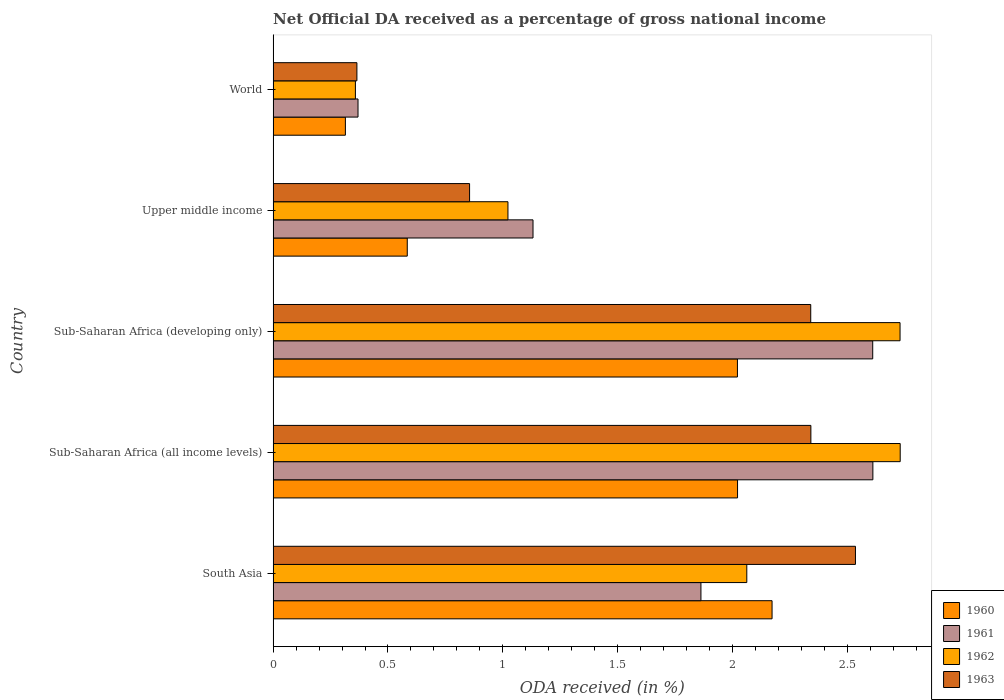Are the number of bars per tick equal to the number of legend labels?
Your answer should be very brief. Yes. How many bars are there on the 1st tick from the top?
Provide a succinct answer. 4. What is the label of the 4th group of bars from the top?
Make the answer very short. Sub-Saharan Africa (all income levels). What is the net official DA received in 1961 in Sub-Saharan Africa (all income levels)?
Keep it short and to the point. 2.61. Across all countries, what is the maximum net official DA received in 1960?
Make the answer very short. 2.17. Across all countries, what is the minimum net official DA received in 1960?
Offer a terse response. 0.31. In which country was the net official DA received in 1960 maximum?
Offer a terse response. South Asia. What is the total net official DA received in 1963 in the graph?
Your answer should be compact. 8.44. What is the difference between the net official DA received in 1961 in South Asia and that in Sub-Saharan Africa (all income levels)?
Provide a short and direct response. -0.75. What is the difference between the net official DA received in 1960 in Sub-Saharan Africa (all income levels) and the net official DA received in 1961 in Upper middle income?
Ensure brevity in your answer.  0.89. What is the average net official DA received in 1962 per country?
Offer a terse response. 1.78. What is the difference between the net official DA received in 1960 and net official DA received in 1961 in World?
Offer a very short reply. -0.05. In how many countries, is the net official DA received in 1961 greater than 1.3 %?
Give a very brief answer. 3. What is the ratio of the net official DA received in 1961 in South Asia to that in World?
Offer a very short reply. 5.04. What is the difference between the highest and the second highest net official DA received in 1963?
Your response must be concise. 0.19. What is the difference between the highest and the lowest net official DA received in 1962?
Provide a short and direct response. 2.37. Is it the case that in every country, the sum of the net official DA received in 1961 and net official DA received in 1960 is greater than the sum of net official DA received in 1962 and net official DA received in 1963?
Offer a very short reply. No. How many bars are there?
Make the answer very short. 20. How many countries are there in the graph?
Make the answer very short. 5. What is the difference between two consecutive major ticks on the X-axis?
Give a very brief answer. 0.5. Does the graph contain grids?
Give a very brief answer. No. Where does the legend appear in the graph?
Your response must be concise. Bottom right. How are the legend labels stacked?
Make the answer very short. Vertical. What is the title of the graph?
Your response must be concise. Net Official DA received as a percentage of gross national income. What is the label or title of the X-axis?
Give a very brief answer. ODA received (in %). What is the label or title of the Y-axis?
Your response must be concise. Country. What is the ODA received (in %) of 1960 in South Asia?
Your answer should be very brief. 2.17. What is the ODA received (in %) in 1961 in South Asia?
Your answer should be compact. 1.86. What is the ODA received (in %) in 1962 in South Asia?
Ensure brevity in your answer.  2.06. What is the ODA received (in %) in 1963 in South Asia?
Provide a short and direct response. 2.53. What is the ODA received (in %) in 1960 in Sub-Saharan Africa (all income levels)?
Ensure brevity in your answer.  2.02. What is the ODA received (in %) in 1961 in Sub-Saharan Africa (all income levels)?
Ensure brevity in your answer.  2.61. What is the ODA received (in %) in 1962 in Sub-Saharan Africa (all income levels)?
Ensure brevity in your answer.  2.73. What is the ODA received (in %) of 1963 in Sub-Saharan Africa (all income levels)?
Ensure brevity in your answer.  2.34. What is the ODA received (in %) in 1960 in Sub-Saharan Africa (developing only)?
Keep it short and to the point. 2.02. What is the ODA received (in %) of 1961 in Sub-Saharan Africa (developing only)?
Make the answer very short. 2.61. What is the ODA received (in %) in 1962 in Sub-Saharan Africa (developing only)?
Offer a very short reply. 2.73. What is the ODA received (in %) of 1963 in Sub-Saharan Africa (developing only)?
Keep it short and to the point. 2.34. What is the ODA received (in %) of 1960 in Upper middle income?
Your answer should be compact. 0.58. What is the ODA received (in %) of 1961 in Upper middle income?
Your answer should be very brief. 1.13. What is the ODA received (in %) of 1962 in Upper middle income?
Your response must be concise. 1.02. What is the ODA received (in %) in 1963 in Upper middle income?
Offer a terse response. 0.86. What is the ODA received (in %) of 1960 in World?
Provide a short and direct response. 0.31. What is the ODA received (in %) of 1961 in World?
Ensure brevity in your answer.  0.37. What is the ODA received (in %) in 1962 in World?
Your answer should be compact. 0.36. What is the ODA received (in %) in 1963 in World?
Your answer should be compact. 0.36. Across all countries, what is the maximum ODA received (in %) in 1960?
Make the answer very short. 2.17. Across all countries, what is the maximum ODA received (in %) in 1961?
Provide a succinct answer. 2.61. Across all countries, what is the maximum ODA received (in %) in 1962?
Your response must be concise. 2.73. Across all countries, what is the maximum ODA received (in %) of 1963?
Give a very brief answer. 2.53. Across all countries, what is the minimum ODA received (in %) of 1960?
Offer a terse response. 0.31. Across all countries, what is the minimum ODA received (in %) of 1961?
Provide a short and direct response. 0.37. Across all countries, what is the minimum ODA received (in %) of 1962?
Ensure brevity in your answer.  0.36. Across all countries, what is the minimum ODA received (in %) of 1963?
Make the answer very short. 0.36. What is the total ODA received (in %) of 1960 in the graph?
Provide a short and direct response. 7.11. What is the total ODA received (in %) of 1961 in the graph?
Offer a terse response. 8.58. What is the total ODA received (in %) of 1962 in the graph?
Ensure brevity in your answer.  8.9. What is the total ODA received (in %) of 1963 in the graph?
Provide a short and direct response. 8.44. What is the difference between the ODA received (in %) of 1960 in South Asia and that in Sub-Saharan Africa (all income levels)?
Offer a very short reply. 0.15. What is the difference between the ODA received (in %) in 1961 in South Asia and that in Sub-Saharan Africa (all income levels)?
Provide a succinct answer. -0.75. What is the difference between the ODA received (in %) of 1962 in South Asia and that in Sub-Saharan Africa (all income levels)?
Your response must be concise. -0.67. What is the difference between the ODA received (in %) in 1963 in South Asia and that in Sub-Saharan Africa (all income levels)?
Your answer should be very brief. 0.19. What is the difference between the ODA received (in %) in 1960 in South Asia and that in Sub-Saharan Africa (developing only)?
Offer a terse response. 0.15. What is the difference between the ODA received (in %) of 1961 in South Asia and that in Sub-Saharan Africa (developing only)?
Provide a succinct answer. -0.75. What is the difference between the ODA received (in %) in 1962 in South Asia and that in Sub-Saharan Africa (developing only)?
Offer a very short reply. -0.67. What is the difference between the ODA received (in %) in 1963 in South Asia and that in Sub-Saharan Africa (developing only)?
Make the answer very short. 0.19. What is the difference between the ODA received (in %) of 1960 in South Asia and that in Upper middle income?
Your response must be concise. 1.59. What is the difference between the ODA received (in %) in 1961 in South Asia and that in Upper middle income?
Provide a short and direct response. 0.73. What is the difference between the ODA received (in %) of 1962 in South Asia and that in Upper middle income?
Provide a short and direct response. 1.04. What is the difference between the ODA received (in %) of 1963 in South Asia and that in Upper middle income?
Provide a short and direct response. 1.68. What is the difference between the ODA received (in %) in 1960 in South Asia and that in World?
Your answer should be compact. 1.86. What is the difference between the ODA received (in %) in 1961 in South Asia and that in World?
Provide a succinct answer. 1.49. What is the difference between the ODA received (in %) of 1962 in South Asia and that in World?
Offer a very short reply. 1.7. What is the difference between the ODA received (in %) in 1963 in South Asia and that in World?
Offer a very short reply. 2.17. What is the difference between the ODA received (in %) in 1960 in Sub-Saharan Africa (all income levels) and that in Sub-Saharan Africa (developing only)?
Offer a terse response. 0. What is the difference between the ODA received (in %) in 1961 in Sub-Saharan Africa (all income levels) and that in Sub-Saharan Africa (developing only)?
Your response must be concise. 0. What is the difference between the ODA received (in %) of 1962 in Sub-Saharan Africa (all income levels) and that in Sub-Saharan Africa (developing only)?
Give a very brief answer. 0. What is the difference between the ODA received (in %) in 1963 in Sub-Saharan Africa (all income levels) and that in Sub-Saharan Africa (developing only)?
Provide a short and direct response. 0. What is the difference between the ODA received (in %) in 1960 in Sub-Saharan Africa (all income levels) and that in Upper middle income?
Provide a succinct answer. 1.44. What is the difference between the ODA received (in %) in 1961 in Sub-Saharan Africa (all income levels) and that in Upper middle income?
Give a very brief answer. 1.48. What is the difference between the ODA received (in %) in 1962 in Sub-Saharan Africa (all income levels) and that in Upper middle income?
Provide a succinct answer. 1.71. What is the difference between the ODA received (in %) in 1963 in Sub-Saharan Africa (all income levels) and that in Upper middle income?
Offer a terse response. 1.49. What is the difference between the ODA received (in %) in 1960 in Sub-Saharan Africa (all income levels) and that in World?
Your answer should be compact. 1.71. What is the difference between the ODA received (in %) in 1961 in Sub-Saharan Africa (all income levels) and that in World?
Ensure brevity in your answer.  2.24. What is the difference between the ODA received (in %) of 1962 in Sub-Saharan Africa (all income levels) and that in World?
Keep it short and to the point. 2.37. What is the difference between the ODA received (in %) of 1963 in Sub-Saharan Africa (all income levels) and that in World?
Keep it short and to the point. 1.98. What is the difference between the ODA received (in %) in 1960 in Sub-Saharan Africa (developing only) and that in Upper middle income?
Ensure brevity in your answer.  1.44. What is the difference between the ODA received (in %) of 1961 in Sub-Saharan Africa (developing only) and that in Upper middle income?
Provide a succinct answer. 1.48. What is the difference between the ODA received (in %) of 1962 in Sub-Saharan Africa (developing only) and that in Upper middle income?
Offer a terse response. 1.71. What is the difference between the ODA received (in %) of 1963 in Sub-Saharan Africa (developing only) and that in Upper middle income?
Provide a short and direct response. 1.49. What is the difference between the ODA received (in %) of 1960 in Sub-Saharan Africa (developing only) and that in World?
Your answer should be compact. 1.71. What is the difference between the ODA received (in %) in 1961 in Sub-Saharan Africa (developing only) and that in World?
Ensure brevity in your answer.  2.24. What is the difference between the ODA received (in %) of 1962 in Sub-Saharan Africa (developing only) and that in World?
Provide a succinct answer. 2.37. What is the difference between the ODA received (in %) in 1963 in Sub-Saharan Africa (developing only) and that in World?
Keep it short and to the point. 1.98. What is the difference between the ODA received (in %) in 1960 in Upper middle income and that in World?
Offer a terse response. 0.27. What is the difference between the ODA received (in %) in 1961 in Upper middle income and that in World?
Ensure brevity in your answer.  0.76. What is the difference between the ODA received (in %) of 1962 in Upper middle income and that in World?
Keep it short and to the point. 0.66. What is the difference between the ODA received (in %) of 1963 in Upper middle income and that in World?
Offer a very short reply. 0.49. What is the difference between the ODA received (in %) in 1960 in South Asia and the ODA received (in %) in 1961 in Sub-Saharan Africa (all income levels)?
Give a very brief answer. -0.44. What is the difference between the ODA received (in %) of 1960 in South Asia and the ODA received (in %) of 1962 in Sub-Saharan Africa (all income levels)?
Offer a very short reply. -0.56. What is the difference between the ODA received (in %) in 1960 in South Asia and the ODA received (in %) in 1963 in Sub-Saharan Africa (all income levels)?
Your answer should be very brief. -0.17. What is the difference between the ODA received (in %) in 1961 in South Asia and the ODA received (in %) in 1962 in Sub-Saharan Africa (all income levels)?
Keep it short and to the point. -0.87. What is the difference between the ODA received (in %) of 1961 in South Asia and the ODA received (in %) of 1963 in Sub-Saharan Africa (all income levels)?
Provide a short and direct response. -0.48. What is the difference between the ODA received (in %) of 1962 in South Asia and the ODA received (in %) of 1963 in Sub-Saharan Africa (all income levels)?
Offer a terse response. -0.28. What is the difference between the ODA received (in %) in 1960 in South Asia and the ODA received (in %) in 1961 in Sub-Saharan Africa (developing only)?
Keep it short and to the point. -0.44. What is the difference between the ODA received (in %) of 1960 in South Asia and the ODA received (in %) of 1962 in Sub-Saharan Africa (developing only)?
Your answer should be very brief. -0.56. What is the difference between the ODA received (in %) in 1960 in South Asia and the ODA received (in %) in 1963 in Sub-Saharan Africa (developing only)?
Keep it short and to the point. -0.17. What is the difference between the ODA received (in %) of 1961 in South Asia and the ODA received (in %) of 1962 in Sub-Saharan Africa (developing only)?
Your response must be concise. -0.87. What is the difference between the ODA received (in %) of 1961 in South Asia and the ODA received (in %) of 1963 in Sub-Saharan Africa (developing only)?
Make the answer very short. -0.48. What is the difference between the ODA received (in %) of 1962 in South Asia and the ODA received (in %) of 1963 in Sub-Saharan Africa (developing only)?
Offer a terse response. -0.28. What is the difference between the ODA received (in %) of 1960 in South Asia and the ODA received (in %) of 1961 in Upper middle income?
Offer a terse response. 1.04. What is the difference between the ODA received (in %) of 1960 in South Asia and the ODA received (in %) of 1962 in Upper middle income?
Keep it short and to the point. 1.15. What is the difference between the ODA received (in %) in 1960 in South Asia and the ODA received (in %) in 1963 in Upper middle income?
Your answer should be very brief. 1.32. What is the difference between the ODA received (in %) of 1961 in South Asia and the ODA received (in %) of 1962 in Upper middle income?
Provide a succinct answer. 0.84. What is the difference between the ODA received (in %) of 1961 in South Asia and the ODA received (in %) of 1963 in Upper middle income?
Ensure brevity in your answer.  1.01. What is the difference between the ODA received (in %) in 1962 in South Asia and the ODA received (in %) in 1963 in Upper middle income?
Offer a terse response. 1.21. What is the difference between the ODA received (in %) of 1960 in South Asia and the ODA received (in %) of 1961 in World?
Your answer should be very brief. 1.8. What is the difference between the ODA received (in %) of 1960 in South Asia and the ODA received (in %) of 1962 in World?
Offer a terse response. 1.81. What is the difference between the ODA received (in %) in 1960 in South Asia and the ODA received (in %) in 1963 in World?
Give a very brief answer. 1.81. What is the difference between the ODA received (in %) in 1961 in South Asia and the ODA received (in %) in 1962 in World?
Offer a very short reply. 1.5. What is the difference between the ODA received (in %) in 1961 in South Asia and the ODA received (in %) in 1963 in World?
Give a very brief answer. 1.5. What is the difference between the ODA received (in %) of 1962 in South Asia and the ODA received (in %) of 1963 in World?
Your answer should be compact. 1.7. What is the difference between the ODA received (in %) of 1960 in Sub-Saharan Africa (all income levels) and the ODA received (in %) of 1961 in Sub-Saharan Africa (developing only)?
Your answer should be compact. -0.59. What is the difference between the ODA received (in %) in 1960 in Sub-Saharan Africa (all income levels) and the ODA received (in %) in 1962 in Sub-Saharan Africa (developing only)?
Make the answer very short. -0.71. What is the difference between the ODA received (in %) in 1960 in Sub-Saharan Africa (all income levels) and the ODA received (in %) in 1963 in Sub-Saharan Africa (developing only)?
Your answer should be compact. -0.32. What is the difference between the ODA received (in %) in 1961 in Sub-Saharan Africa (all income levels) and the ODA received (in %) in 1962 in Sub-Saharan Africa (developing only)?
Your answer should be compact. -0.12. What is the difference between the ODA received (in %) in 1961 in Sub-Saharan Africa (all income levels) and the ODA received (in %) in 1963 in Sub-Saharan Africa (developing only)?
Ensure brevity in your answer.  0.27. What is the difference between the ODA received (in %) of 1962 in Sub-Saharan Africa (all income levels) and the ODA received (in %) of 1963 in Sub-Saharan Africa (developing only)?
Give a very brief answer. 0.39. What is the difference between the ODA received (in %) in 1960 in Sub-Saharan Africa (all income levels) and the ODA received (in %) in 1961 in Upper middle income?
Your answer should be very brief. 0.89. What is the difference between the ODA received (in %) in 1960 in Sub-Saharan Africa (all income levels) and the ODA received (in %) in 1962 in Upper middle income?
Offer a very short reply. 1. What is the difference between the ODA received (in %) in 1960 in Sub-Saharan Africa (all income levels) and the ODA received (in %) in 1963 in Upper middle income?
Provide a succinct answer. 1.17. What is the difference between the ODA received (in %) of 1961 in Sub-Saharan Africa (all income levels) and the ODA received (in %) of 1962 in Upper middle income?
Your response must be concise. 1.59. What is the difference between the ODA received (in %) in 1961 in Sub-Saharan Africa (all income levels) and the ODA received (in %) in 1963 in Upper middle income?
Keep it short and to the point. 1.76. What is the difference between the ODA received (in %) of 1962 in Sub-Saharan Africa (all income levels) and the ODA received (in %) of 1963 in Upper middle income?
Ensure brevity in your answer.  1.87. What is the difference between the ODA received (in %) in 1960 in Sub-Saharan Africa (all income levels) and the ODA received (in %) in 1961 in World?
Offer a terse response. 1.65. What is the difference between the ODA received (in %) of 1960 in Sub-Saharan Africa (all income levels) and the ODA received (in %) of 1962 in World?
Your response must be concise. 1.66. What is the difference between the ODA received (in %) of 1960 in Sub-Saharan Africa (all income levels) and the ODA received (in %) of 1963 in World?
Your answer should be very brief. 1.66. What is the difference between the ODA received (in %) in 1961 in Sub-Saharan Africa (all income levels) and the ODA received (in %) in 1962 in World?
Offer a terse response. 2.25. What is the difference between the ODA received (in %) of 1961 in Sub-Saharan Africa (all income levels) and the ODA received (in %) of 1963 in World?
Give a very brief answer. 2.25. What is the difference between the ODA received (in %) in 1962 in Sub-Saharan Africa (all income levels) and the ODA received (in %) in 1963 in World?
Make the answer very short. 2.37. What is the difference between the ODA received (in %) in 1960 in Sub-Saharan Africa (developing only) and the ODA received (in %) in 1961 in Upper middle income?
Ensure brevity in your answer.  0.89. What is the difference between the ODA received (in %) in 1960 in Sub-Saharan Africa (developing only) and the ODA received (in %) in 1963 in Upper middle income?
Make the answer very short. 1.17. What is the difference between the ODA received (in %) of 1961 in Sub-Saharan Africa (developing only) and the ODA received (in %) of 1962 in Upper middle income?
Offer a very short reply. 1.59. What is the difference between the ODA received (in %) in 1961 in Sub-Saharan Africa (developing only) and the ODA received (in %) in 1963 in Upper middle income?
Your answer should be very brief. 1.75. What is the difference between the ODA received (in %) of 1962 in Sub-Saharan Africa (developing only) and the ODA received (in %) of 1963 in Upper middle income?
Provide a short and direct response. 1.87. What is the difference between the ODA received (in %) in 1960 in Sub-Saharan Africa (developing only) and the ODA received (in %) in 1961 in World?
Give a very brief answer. 1.65. What is the difference between the ODA received (in %) of 1960 in Sub-Saharan Africa (developing only) and the ODA received (in %) of 1962 in World?
Keep it short and to the point. 1.66. What is the difference between the ODA received (in %) in 1960 in Sub-Saharan Africa (developing only) and the ODA received (in %) in 1963 in World?
Give a very brief answer. 1.66. What is the difference between the ODA received (in %) of 1961 in Sub-Saharan Africa (developing only) and the ODA received (in %) of 1962 in World?
Your answer should be very brief. 2.25. What is the difference between the ODA received (in %) in 1961 in Sub-Saharan Africa (developing only) and the ODA received (in %) in 1963 in World?
Provide a short and direct response. 2.25. What is the difference between the ODA received (in %) of 1962 in Sub-Saharan Africa (developing only) and the ODA received (in %) of 1963 in World?
Give a very brief answer. 2.36. What is the difference between the ODA received (in %) in 1960 in Upper middle income and the ODA received (in %) in 1961 in World?
Offer a very short reply. 0.21. What is the difference between the ODA received (in %) of 1960 in Upper middle income and the ODA received (in %) of 1962 in World?
Offer a very short reply. 0.23. What is the difference between the ODA received (in %) in 1960 in Upper middle income and the ODA received (in %) in 1963 in World?
Offer a very short reply. 0.22. What is the difference between the ODA received (in %) in 1961 in Upper middle income and the ODA received (in %) in 1962 in World?
Your answer should be very brief. 0.77. What is the difference between the ODA received (in %) in 1961 in Upper middle income and the ODA received (in %) in 1963 in World?
Ensure brevity in your answer.  0.77. What is the difference between the ODA received (in %) of 1962 in Upper middle income and the ODA received (in %) of 1963 in World?
Make the answer very short. 0.66. What is the average ODA received (in %) of 1960 per country?
Keep it short and to the point. 1.42. What is the average ODA received (in %) of 1961 per country?
Your response must be concise. 1.72. What is the average ODA received (in %) of 1962 per country?
Your answer should be very brief. 1.78. What is the average ODA received (in %) of 1963 per country?
Keep it short and to the point. 1.69. What is the difference between the ODA received (in %) in 1960 and ODA received (in %) in 1961 in South Asia?
Keep it short and to the point. 0.31. What is the difference between the ODA received (in %) of 1960 and ODA received (in %) of 1962 in South Asia?
Provide a succinct answer. 0.11. What is the difference between the ODA received (in %) in 1960 and ODA received (in %) in 1963 in South Asia?
Offer a very short reply. -0.36. What is the difference between the ODA received (in %) of 1961 and ODA received (in %) of 1962 in South Asia?
Offer a terse response. -0.2. What is the difference between the ODA received (in %) in 1961 and ODA received (in %) in 1963 in South Asia?
Your answer should be very brief. -0.67. What is the difference between the ODA received (in %) of 1962 and ODA received (in %) of 1963 in South Asia?
Your answer should be compact. -0.47. What is the difference between the ODA received (in %) of 1960 and ODA received (in %) of 1961 in Sub-Saharan Africa (all income levels)?
Give a very brief answer. -0.59. What is the difference between the ODA received (in %) in 1960 and ODA received (in %) in 1962 in Sub-Saharan Africa (all income levels)?
Provide a short and direct response. -0.71. What is the difference between the ODA received (in %) of 1960 and ODA received (in %) of 1963 in Sub-Saharan Africa (all income levels)?
Offer a terse response. -0.32. What is the difference between the ODA received (in %) of 1961 and ODA received (in %) of 1962 in Sub-Saharan Africa (all income levels)?
Give a very brief answer. -0.12. What is the difference between the ODA received (in %) of 1961 and ODA received (in %) of 1963 in Sub-Saharan Africa (all income levels)?
Make the answer very short. 0.27. What is the difference between the ODA received (in %) of 1962 and ODA received (in %) of 1963 in Sub-Saharan Africa (all income levels)?
Offer a terse response. 0.39. What is the difference between the ODA received (in %) of 1960 and ODA received (in %) of 1961 in Sub-Saharan Africa (developing only)?
Provide a succinct answer. -0.59. What is the difference between the ODA received (in %) in 1960 and ODA received (in %) in 1962 in Sub-Saharan Africa (developing only)?
Ensure brevity in your answer.  -0.71. What is the difference between the ODA received (in %) of 1960 and ODA received (in %) of 1963 in Sub-Saharan Africa (developing only)?
Offer a very short reply. -0.32. What is the difference between the ODA received (in %) in 1961 and ODA received (in %) in 1962 in Sub-Saharan Africa (developing only)?
Make the answer very short. -0.12. What is the difference between the ODA received (in %) of 1961 and ODA received (in %) of 1963 in Sub-Saharan Africa (developing only)?
Give a very brief answer. 0.27. What is the difference between the ODA received (in %) of 1962 and ODA received (in %) of 1963 in Sub-Saharan Africa (developing only)?
Offer a terse response. 0.39. What is the difference between the ODA received (in %) in 1960 and ODA received (in %) in 1961 in Upper middle income?
Keep it short and to the point. -0.55. What is the difference between the ODA received (in %) in 1960 and ODA received (in %) in 1962 in Upper middle income?
Your answer should be very brief. -0.44. What is the difference between the ODA received (in %) of 1960 and ODA received (in %) of 1963 in Upper middle income?
Provide a succinct answer. -0.27. What is the difference between the ODA received (in %) in 1961 and ODA received (in %) in 1962 in Upper middle income?
Your answer should be compact. 0.11. What is the difference between the ODA received (in %) of 1961 and ODA received (in %) of 1963 in Upper middle income?
Offer a very short reply. 0.28. What is the difference between the ODA received (in %) in 1962 and ODA received (in %) in 1963 in Upper middle income?
Provide a short and direct response. 0.17. What is the difference between the ODA received (in %) of 1960 and ODA received (in %) of 1961 in World?
Ensure brevity in your answer.  -0.06. What is the difference between the ODA received (in %) in 1960 and ODA received (in %) in 1962 in World?
Keep it short and to the point. -0.04. What is the difference between the ODA received (in %) of 1960 and ODA received (in %) of 1963 in World?
Your answer should be compact. -0.05. What is the difference between the ODA received (in %) of 1961 and ODA received (in %) of 1962 in World?
Offer a very short reply. 0.01. What is the difference between the ODA received (in %) of 1961 and ODA received (in %) of 1963 in World?
Your response must be concise. 0. What is the difference between the ODA received (in %) of 1962 and ODA received (in %) of 1963 in World?
Your response must be concise. -0.01. What is the ratio of the ODA received (in %) in 1960 in South Asia to that in Sub-Saharan Africa (all income levels)?
Your answer should be very brief. 1.07. What is the ratio of the ODA received (in %) of 1961 in South Asia to that in Sub-Saharan Africa (all income levels)?
Make the answer very short. 0.71. What is the ratio of the ODA received (in %) of 1962 in South Asia to that in Sub-Saharan Africa (all income levels)?
Your response must be concise. 0.76. What is the ratio of the ODA received (in %) in 1963 in South Asia to that in Sub-Saharan Africa (all income levels)?
Offer a terse response. 1.08. What is the ratio of the ODA received (in %) of 1960 in South Asia to that in Sub-Saharan Africa (developing only)?
Your response must be concise. 1.07. What is the ratio of the ODA received (in %) of 1961 in South Asia to that in Sub-Saharan Africa (developing only)?
Give a very brief answer. 0.71. What is the ratio of the ODA received (in %) of 1962 in South Asia to that in Sub-Saharan Africa (developing only)?
Your answer should be very brief. 0.76. What is the ratio of the ODA received (in %) of 1963 in South Asia to that in Sub-Saharan Africa (developing only)?
Offer a terse response. 1.08. What is the ratio of the ODA received (in %) of 1960 in South Asia to that in Upper middle income?
Make the answer very short. 3.72. What is the ratio of the ODA received (in %) in 1961 in South Asia to that in Upper middle income?
Provide a succinct answer. 1.65. What is the ratio of the ODA received (in %) in 1962 in South Asia to that in Upper middle income?
Ensure brevity in your answer.  2.02. What is the ratio of the ODA received (in %) in 1963 in South Asia to that in Upper middle income?
Keep it short and to the point. 2.96. What is the ratio of the ODA received (in %) of 1960 in South Asia to that in World?
Offer a terse response. 6.9. What is the ratio of the ODA received (in %) in 1961 in South Asia to that in World?
Give a very brief answer. 5.04. What is the ratio of the ODA received (in %) in 1962 in South Asia to that in World?
Keep it short and to the point. 5.76. What is the ratio of the ODA received (in %) in 1963 in South Asia to that in World?
Your answer should be very brief. 6.95. What is the ratio of the ODA received (in %) of 1960 in Sub-Saharan Africa (all income levels) to that in Sub-Saharan Africa (developing only)?
Provide a succinct answer. 1. What is the ratio of the ODA received (in %) of 1960 in Sub-Saharan Africa (all income levels) to that in Upper middle income?
Offer a very short reply. 3.46. What is the ratio of the ODA received (in %) of 1961 in Sub-Saharan Africa (all income levels) to that in Upper middle income?
Offer a very short reply. 2.31. What is the ratio of the ODA received (in %) in 1962 in Sub-Saharan Africa (all income levels) to that in Upper middle income?
Offer a very short reply. 2.67. What is the ratio of the ODA received (in %) in 1963 in Sub-Saharan Africa (all income levels) to that in Upper middle income?
Your answer should be very brief. 2.74. What is the ratio of the ODA received (in %) of 1960 in Sub-Saharan Africa (all income levels) to that in World?
Make the answer very short. 6.43. What is the ratio of the ODA received (in %) in 1961 in Sub-Saharan Africa (all income levels) to that in World?
Offer a very short reply. 7.07. What is the ratio of the ODA received (in %) in 1962 in Sub-Saharan Africa (all income levels) to that in World?
Offer a very short reply. 7.62. What is the ratio of the ODA received (in %) of 1963 in Sub-Saharan Africa (all income levels) to that in World?
Offer a terse response. 6.42. What is the ratio of the ODA received (in %) in 1960 in Sub-Saharan Africa (developing only) to that in Upper middle income?
Provide a short and direct response. 3.46. What is the ratio of the ODA received (in %) in 1961 in Sub-Saharan Africa (developing only) to that in Upper middle income?
Give a very brief answer. 2.31. What is the ratio of the ODA received (in %) in 1962 in Sub-Saharan Africa (developing only) to that in Upper middle income?
Offer a terse response. 2.67. What is the ratio of the ODA received (in %) of 1963 in Sub-Saharan Africa (developing only) to that in Upper middle income?
Make the answer very short. 2.74. What is the ratio of the ODA received (in %) of 1960 in Sub-Saharan Africa (developing only) to that in World?
Provide a succinct answer. 6.43. What is the ratio of the ODA received (in %) of 1961 in Sub-Saharan Africa (developing only) to that in World?
Your answer should be compact. 7.06. What is the ratio of the ODA received (in %) of 1962 in Sub-Saharan Africa (developing only) to that in World?
Offer a very short reply. 7.62. What is the ratio of the ODA received (in %) of 1963 in Sub-Saharan Africa (developing only) to that in World?
Keep it short and to the point. 6.42. What is the ratio of the ODA received (in %) in 1960 in Upper middle income to that in World?
Your answer should be compact. 1.86. What is the ratio of the ODA received (in %) of 1961 in Upper middle income to that in World?
Ensure brevity in your answer.  3.06. What is the ratio of the ODA received (in %) in 1962 in Upper middle income to that in World?
Ensure brevity in your answer.  2.85. What is the ratio of the ODA received (in %) in 1963 in Upper middle income to that in World?
Your answer should be compact. 2.34. What is the difference between the highest and the second highest ODA received (in %) in 1960?
Make the answer very short. 0.15. What is the difference between the highest and the second highest ODA received (in %) of 1961?
Your answer should be very brief. 0. What is the difference between the highest and the second highest ODA received (in %) of 1962?
Your response must be concise. 0. What is the difference between the highest and the second highest ODA received (in %) in 1963?
Provide a succinct answer. 0.19. What is the difference between the highest and the lowest ODA received (in %) in 1960?
Ensure brevity in your answer.  1.86. What is the difference between the highest and the lowest ODA received (in %) of 1961?
Provide a short and direct response. 2.24. What is the difference between the highest and the lowest ODA received (in %) of 1962?
Offer a very short reply. 2.37. What is the difference between the highest and the lowest ODA received (in %) in 1963?
Provide a short and direct response. 2.17. 